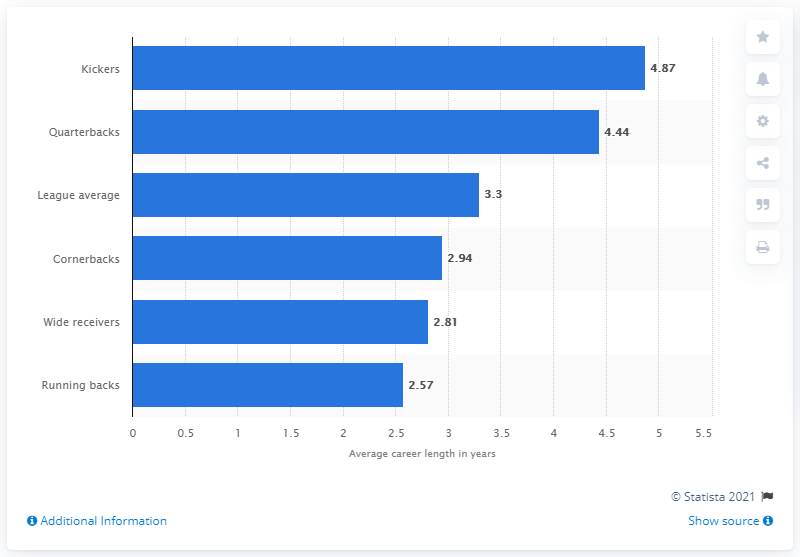Outline some significant characteristics in this image. The maximum playing career length in the National Football League is 1.75 times longer than the median playing career length. The bottom y-axis label in the graph is "Running backs...". 